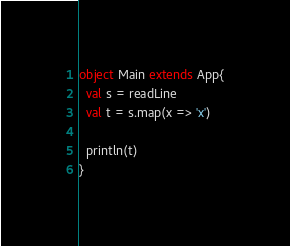<code> <loc_0><loc_0><loc_500><loc_500><_Scala_>object Main extends App{
  val s = readLine
  val t = s.map(x => 'x')
  
  println(t)
}</code> 